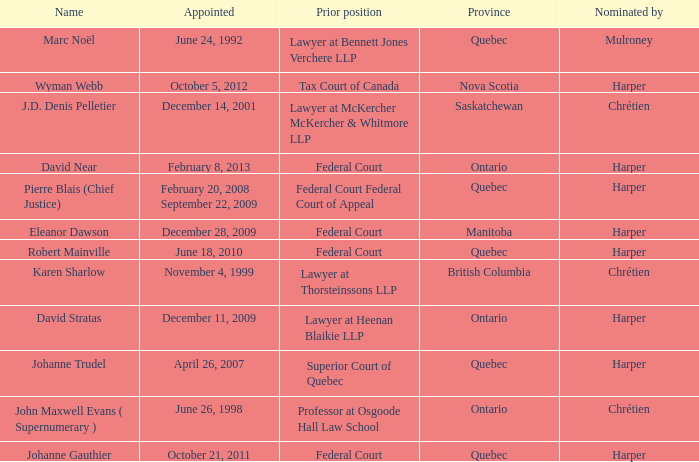What was the prior position held by Wyman Webb? Tax Court of Canada. 